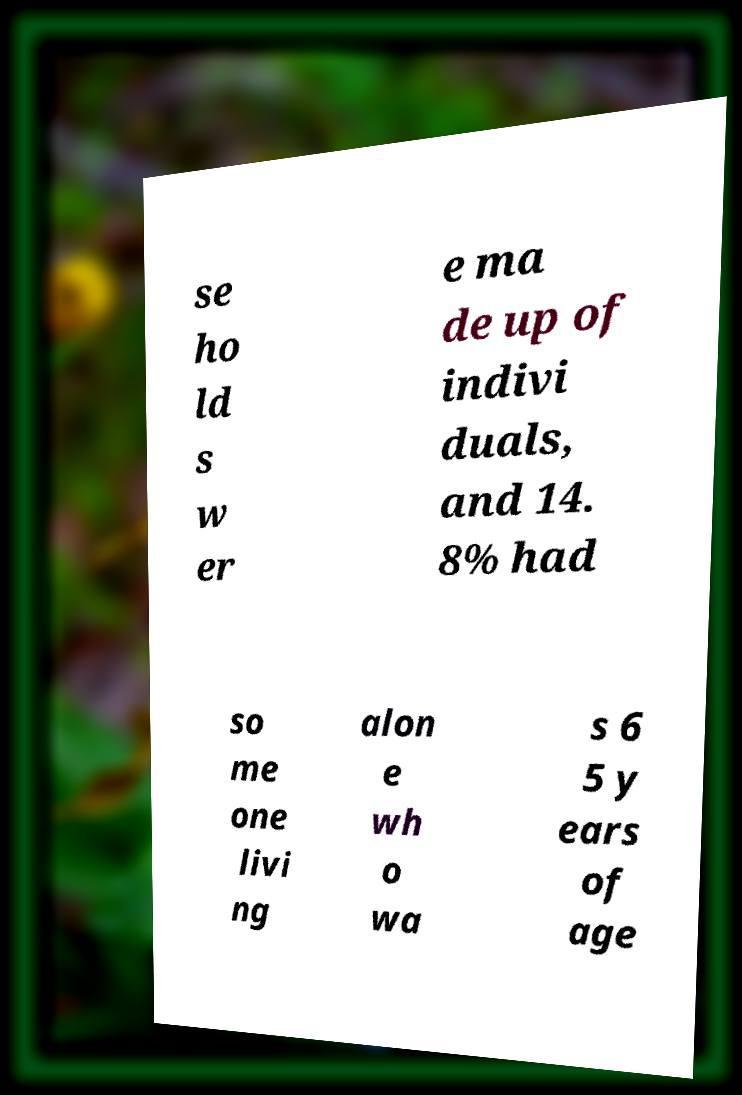What messages or text are displayed in this image? I need them in a readable, typed format. se ho ld s w er e ma de up of indivi duals, and 14. 8% had so me one livi ng alon e wh o wa s 6 5 y ears of age 